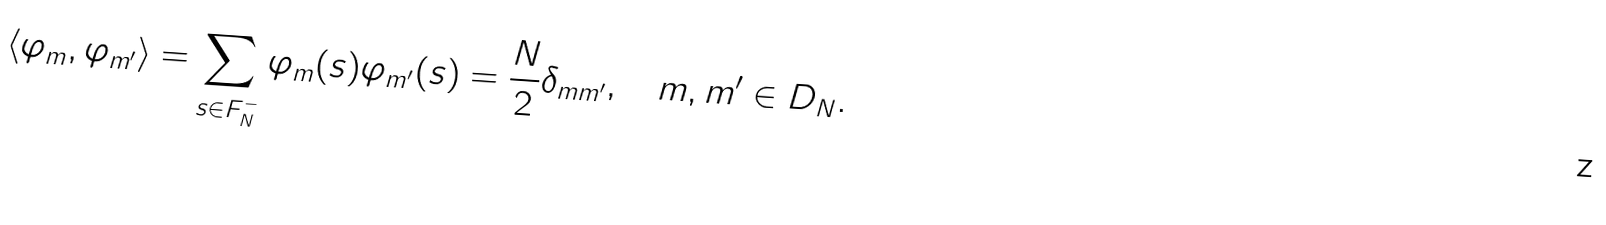Convert formula to latex. <formula><loc_0><loc_0><loc_500><loc_500>\langle \varphi _ { m } , \varphi _ { m ^ { \prime } } \rangle = \sum _ { s \in F _ { N } ^ { - } } \varphi _ { m } ( s ) \varphi _ { m ^ { \prime } } ( s ) = \frac { N } { 2 } \delta _ { m m ^ { \prime } } , \quad m , m ^ { \prime } \in D _ { N } .</formula> 